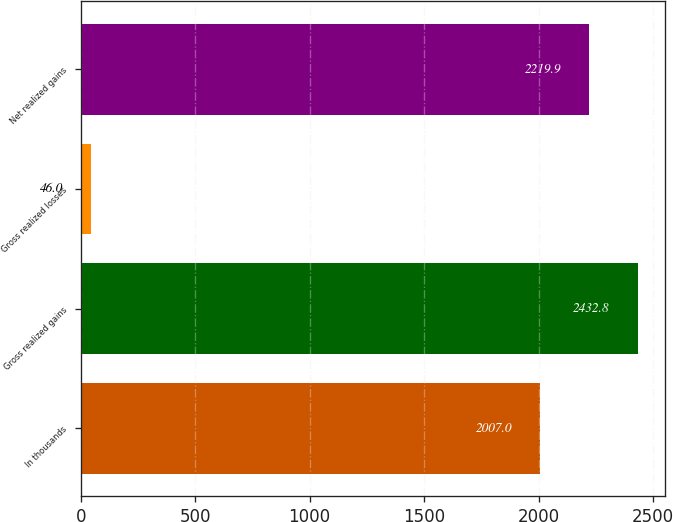Convert chart to OTSL. <chart><loc_0><loc_0><loc_500><loc_500><bar_chart><fcel>In thousands<fcel>Gross realized gains<fcel>Gross realized losses<fcel>Net realized gains<nl><fcel>2007<fcel>2432.8<fcel>46<fcel>2219.9<nl></chart> 